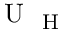<formula> <loc_0><loc_0><loc_500><loc_500>U _ { H }</formula> 